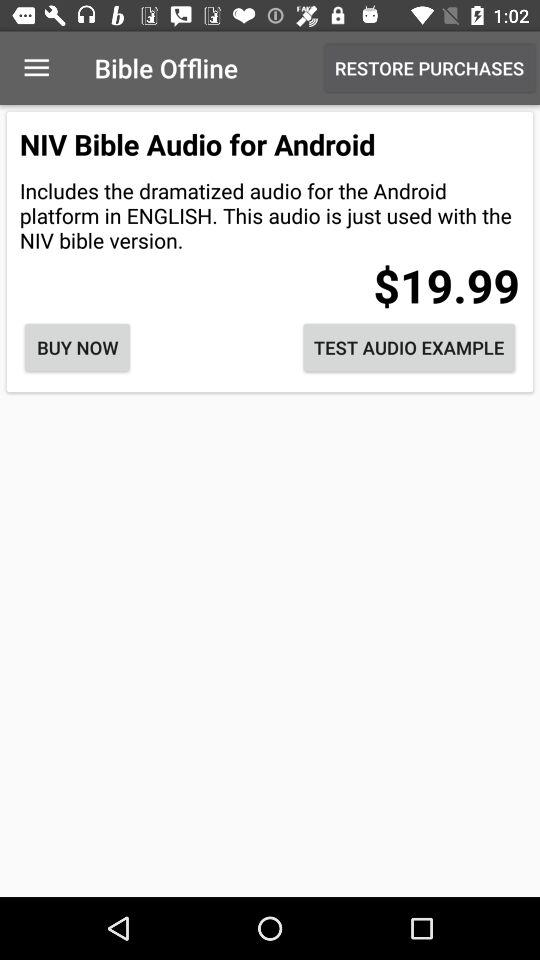How much is the price of the NIV Bible Audio for Android?
Answer the question using a single word or phrase. $19.99 